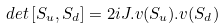<formula> <loc_0><loc_0><loc_500><loc_500>d e t \left [ S _ { u } , S _ { d } \right ] = 2 i J . v ( S _ { u } ) . v ( S _ { d } )</formula> 